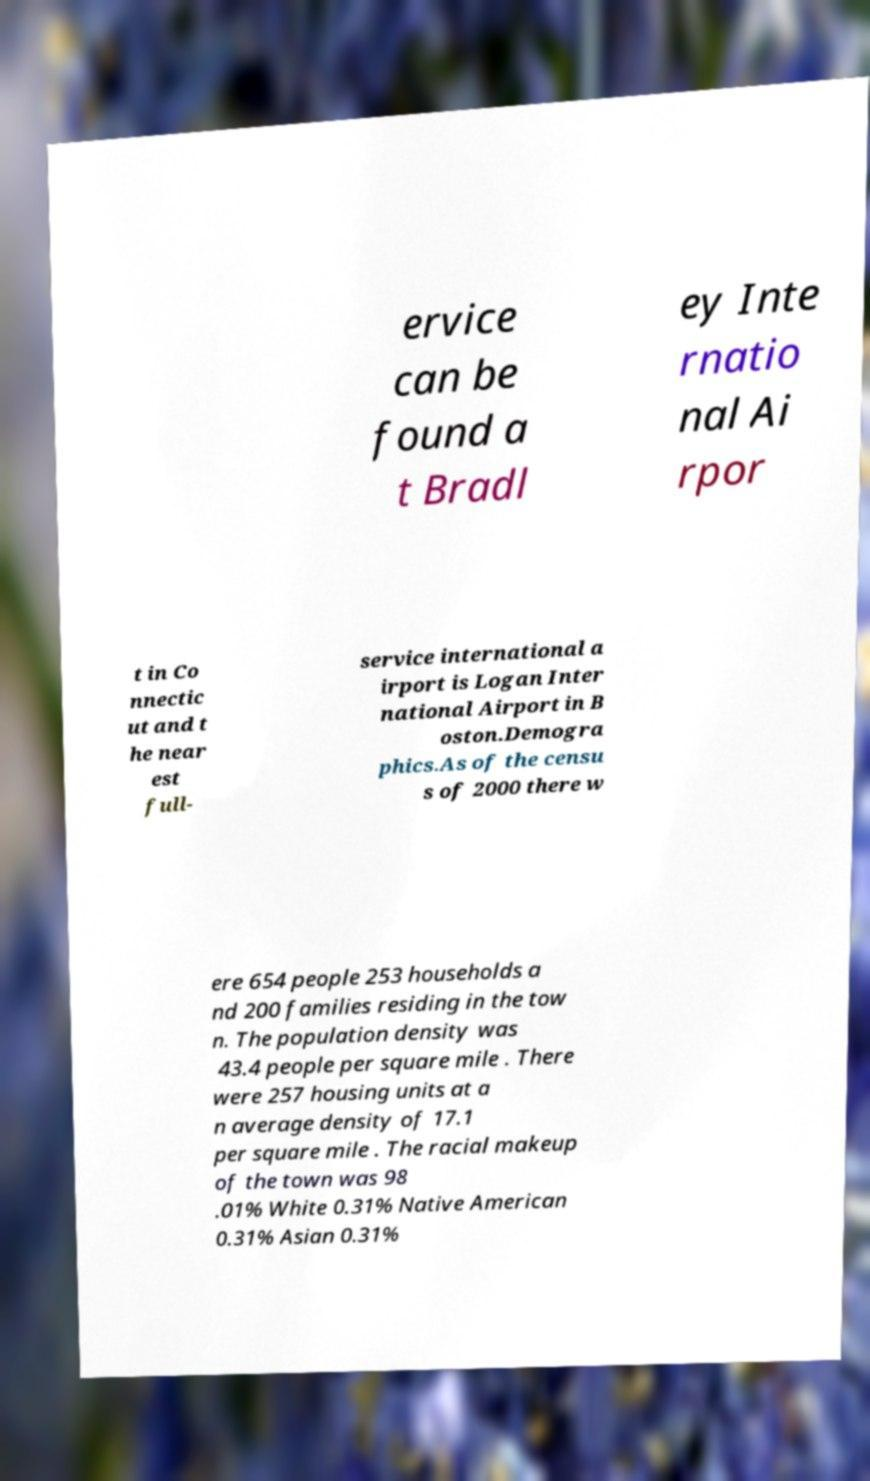Can you accurately transcribe the text from the provided image for me? ervice can be found a t Bradl ey Inte rnatio nal Ai rpor t in Co nnectic ut and t he near est full- service international a irport is Logan Inter national Airport in B oston.Demogra phics.As of the censu s of 2000 there w ere 654 people 253 households a nd 200 families residing in the tow n. The population density was 43.4 people per square mile . There were 257 housing units at a n average density of 17.1 per square mile . The racial makeup of the town was 98 .01% White 0.31% Native American 0.31% Asian 0.31% 